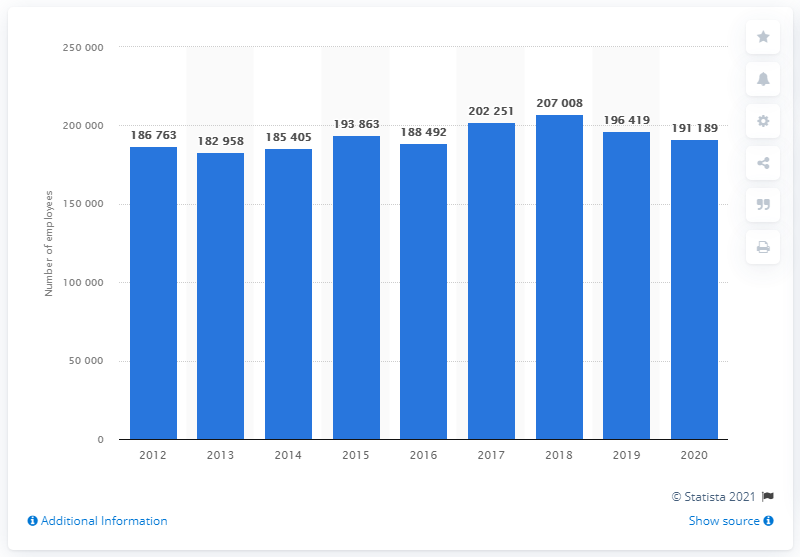Outline some significant characteristics in this image. In 2020, the Banco Santander group had a total of 191,189 employees worldwide. In 2012, the Banco Santander group employed a total of 188,492 people globally. 